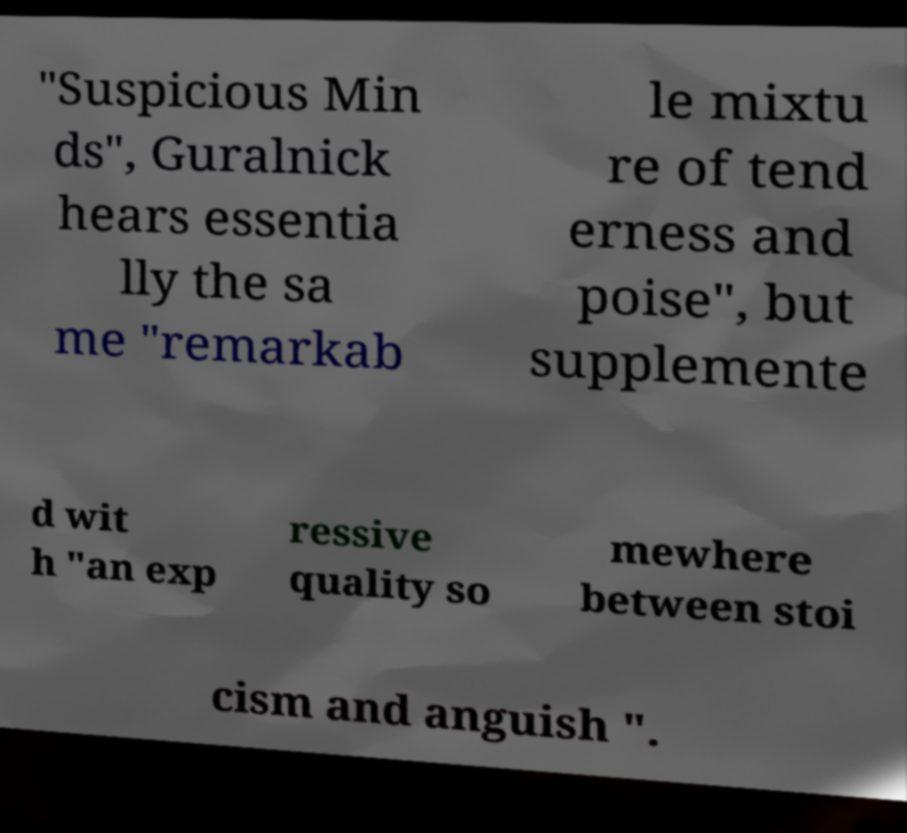Could you extract and type out the text from this image? "Suspicious Min ds", Guralnick hears essentia lly the sa me "remarkab le mixtu re of tend erness and poise", but supplemente d wit h "an exp ressive quality so mewhere between stoi cism and anguish ". 